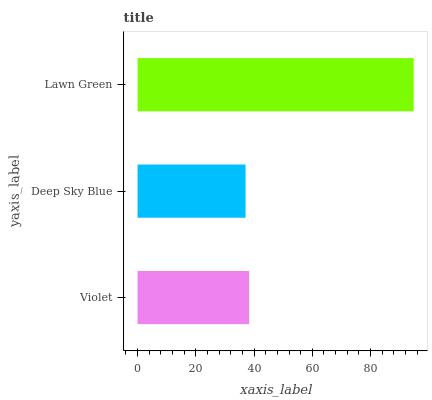Is Deep Sky Blue the minimum?
Answer yes or no. Yes. Is Lawn Green the maximum?
Answer yes or no. Yes. Is Lawn Green the minimum?
Answer yes or no. No. Is Deep Sky Blue the maximum?
Answer yes or no. No. Is Lawn Green greater than Deep Sky Blue?
Answer yes or no. Yes. Is Deep Sky Blue less than Lawn Green?
Answer yes or no. Yes. Is Deep Sky Blue greater than Lawn Green?
Answer yes or no. No. Is Lawn Green less than Deep Sky Blue?
Answer yes or no. No. Is Violet the high median?
Answer yes or no. Yes. Is Violet the low median?
Answer yes or no. Yes. Is Lawn Green the high median?
Answer yes or no. No. Is Lawn Green the low median?
Answer yes or no. No. 